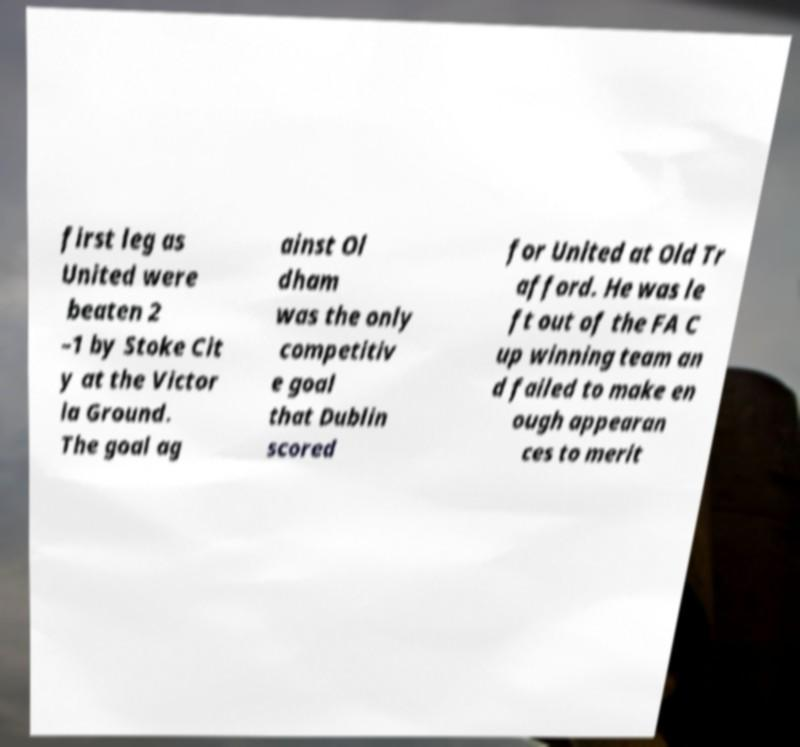For documentation purposes, I need the text within this image transcribed. Could you provide that? first leg as United were beaten 2 –1 by Stoke Cit y at the Victor ia Ground. The goal ag ainst Ol dham was the only competitiv e goal that Dublin scored for United at Old Tr afford. He was le ft out of the FA C up winning team an d failed to make en ough appearan ces to merit 